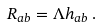<formula> <loc_0><loc_0><loc_500><loc_500>R _ { a b } = \Lambda h _ { a b } \, .</formula> 